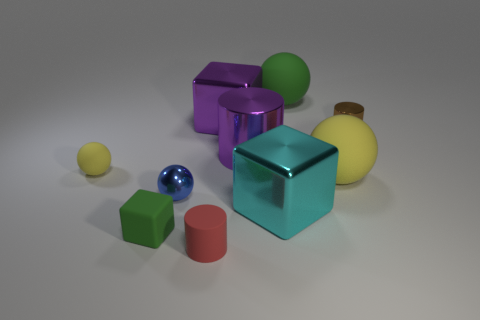If this was a still life painting, what mood would it convey? If this were a still life painting, it would convey a mood of quiet contemplation and modern simplicity. The arrangement of geometric shapes in harmonious colors against the neutral background contributes to a serene and ordered feel. 